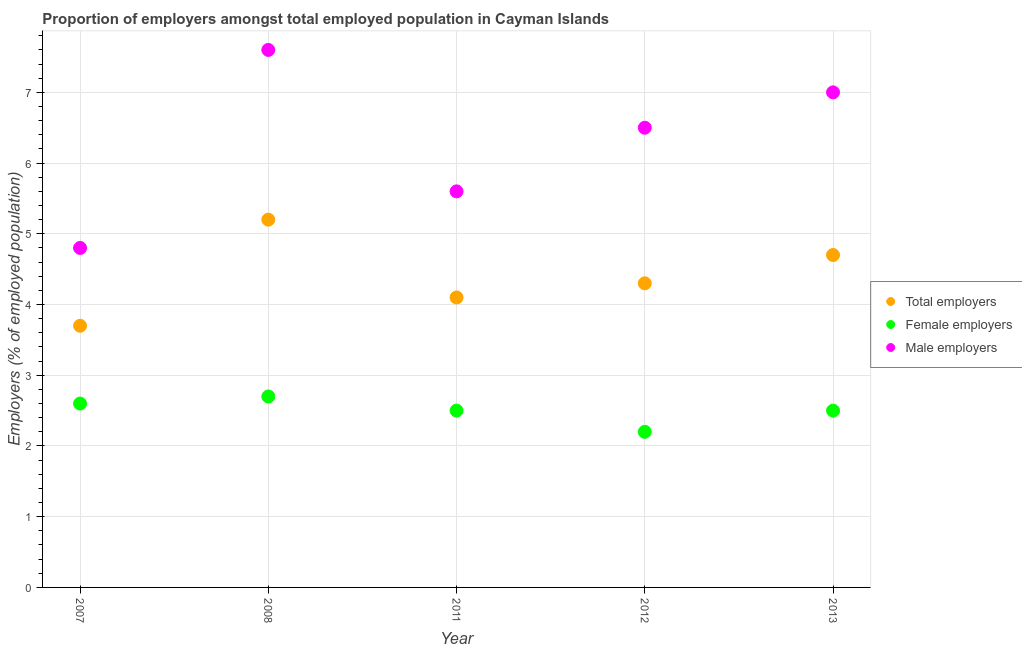What is the percentage of female employers in 2008?
Provide a short and direct response. 2.7. Across all years, what is the maximum percentage of male employers?
Offer a very short reply. 7.6. Across all years, what is the minimum percentage of male employers?
Offer a very short reply. 4.8. In which year was the percentage of female employers maximum?
Your response must be concise. 2008. In which year was the percentage of total employers minimum?
Offer a very short reply. 2007. What is the total percentage of female employers in the graph?
Your answer should be very brief. 12.5. What is the difference between the percentage of female employers in 2008 and that in 2013?
Your answer should be compact. 0.2. What is the difference between the percentage of total employers in 2007 and the percentage of female employers in 2012?
Your answer should be very brief. 1.5. What is the average percentage of female employers per year?
Provide a succinct answer. 2.5. In the year 2011, what is the difference between the percentage of female employers and percentage of total employers?
Provide a short and direct response. -1.6. In how many years, is the percentage of female employers greater than 3.6 %?
Offer a very short reply. 0. What is the ratio of the percentage of total employers in 2011 to that in 2013?
Make the answer very short. 0.87. Is the difference between the percentage of female employers in 2008 and 2013 greater than the difference between the percentage of male employers in 2008 and 2013?
Provide a succinct answer. No. What is the difference between the highest and the lowest percentage of male employers?
Make the answer very short. 2.8. In how many years, is the percentage of total employers greater than the average percentage of total employers taken over all years?
Your answer should be compact. 2. Is the sum of the percentage of female employers in 2008 and 2011 greater than the maximum percentage of male employers across all years?
Provide a short and direct response. No. Is the percentage of female employers strictly less than the percentage of male employers over the years?
Your answer should be compact. Yes. How many dotlines are there?
Your answer should be very brief. 3. How many years are there in the graph?
Your answer should be compact. 5. What is the difference between two consecutive major ticks on the Y-axis?
Your answer should be compact. 1. Are the values on the major ticks of Y-axis written in scientific E-notation?
Ensure brevity in your answer.  No. Does the graph contain any zero values?
Keep it short and to the point. No. How are the legend labels stacked?
Keep it short and to the point. Vertical. What is the title of the graph?
Offer a very short reply. Proportion of employers amongst total employed population in Cayman Islands. Does "Neonatal" appear as one of the legend labels in the graph?
Make the answer very short. No. What is the label or title of the X-axis?
Provide a short and direct response. Year. What is the label or title of the Y-axis?
Give a very brief answer. Employers (% of employed population). What is the Employers (% of employed population) in Total employers in 2007?
Ensure brevity in your answer.  3.7. What is the Employers (% of employed population) in Female employers in 2007?
Ensure brevity in your answer.  2.6. What is the Employers (% of employed population) of Male employers in 2007?
Make the answer very short. 4.8. What is the Employers (% of employed population) of Total employers in 2008?
Ensure brevity in your answer.  5.2. What is the Employers (% of employed population) in Female employers in 2008?
Your answer should be very brief. 2.7. What is the Employers (% of employed population) in Male employers in 2008?
Provide a succinct answer. 7.6. What is the Employers (% of employed population) of Total employers in 2011?
Provide a short and direct response. 4.1. What is the Employers (% of employed population) of Male employers in 2011?
Offer a terse response. 5.6. What is the Employers (% of employed population) of Total employers in 2012?
Provide a short and direct response. 4.3. What is the Employers (% of employed population) of Female employers in 2012?
Your answer should be compact. 2.2. What is the Employers (% of employed population) of Male employers in 2012?
Your answer should be compact. 6.5. What is the Employers (% of employed population) of Total employers in 2013?
Your answer should be very brief. 4.7. What is the Employers (% of employed population) in Male employers in 2013?
Provide a succinct answer. 7. Across all years, what is the maximum Employers (% of employed population) in Total employers?
Your response must be concise. 5.2. Across all years, what is the maximum Employers (% of employed population) in Female employers?
Your answer should be compact. 2.7. Across all years, what is the maximum Employers (% of employed population) in Male employers?
Offer a very short reply. 7.6. Across all years, what is the minimum Employers (% of employed population) of Total employers?
Give a very brief answer. 3.7. Across all years, what is the minimum Employers (% of employed population) of Female employers?
Keep it short and to the point. 2.2. Across all years, what is the minimum Employers (% of employed population) in Male employers?
Your response must be concise. 4.8. What is the total Employers (% of employed population) of Total employers in the graph?
Keep it short and to the point. 22. What is the total Employers (% of employed population) of Male employers in the graph?
Your response must be concise. 31.5. What is the difference between the Employers (% of employed population) in Female employers in 2007 and that in 2008?
Make the answer very short. -0.1. What is the difference between the Employers (% of employed population) of Male employers in 2007 and that in 2008?
Keep it short and to the point. -2.8. What is the difference between the Employers (% of employed population) of Total employers in 2007 and that in 2011?
Your answer should be compact. -0.4. What is the difference between the Employers (% of employed population) in Female employers in 2007 and that in 2011?
Keep it short and to the point. 0.1. What is the difference between the Employers (% of employed population) of Total employers in 2007 and that in 2012?
Your response must be concise. -0.6. What is the difference between the Employers (% of employed population) of Female employers in 2007 and that in 2012?
Keep it short and to the point. 0.4. What is the difference between the Employers (% of employed population) in Total employers in 2008 and that in 2011?
Provide a short and direct response. 1.1. What is the difference between the Employers (% of employed population) of Total employers in 2011 and that in 2012?
Make the answer very short. -0.2. What is the difference between the Employers (% of employed population) in Male employers in 2011 and that in 2012?
Make the answer very short. -0.9. What is the difference between the Employers (% of employed population) in Total employers in 2011 and that in 2013?
Offer a very short reply. -0.6. What is the difference between the Employers (% of employed population) of Female employers in 2011 and that in 2013?
Make the answer very short. 0. What is the difference between the Employers (% of employed population) of Total employers in 2012 and that in 2013?
Offer a very short reply. -0.4. What is the difference between the Employers (% of employed population) in Female employers in 2012 and that in 2013?
Offer a terse response. -0.3. What is the difference between the Employers (% of employed population) of Total employers in 2007 and the Employers (% of employed population) of Female employers in 2011?
Keep it short and to the point. 1.2. What is the difference between the Employers (% of employed population) in Total employers in 2007 and the Employers (% of employed population) in Male employers in 2011?
Offer a very short reply. -1.9. What is the difference between the Employers (% of employed population) of Female employers in 2007 and the Employers (% of employed population) of Male employers in 2011?
Your answer should be very brief. -3. What is the difference between the Employers (% of employed population) in Female employers in 2007 and the Employers (% of employed population) in Male employers in 2013?
Offer a terse response. -4.4. What is the difference between the Employers (% of employed population) in Total employers in 2008 and the Employers (% of employed population) in Male employers in 2011?
Provide a short and direct response. -0.4. What is the difference between the Employers (% of employed population) in Female employers in 2008 and the Employers (% of employed population) in Male employers in 2011?
Offer a terse response. -2.9. What is the difference between the Employers (% of employed population) in Female employers in 2008 and the Employers (% of employed population) in Male employers in 2012?
Offer a very short reply. -3.8. What is the difference between the Employers (% of employed population) of Total employers in 2008 and the Employers (% of employed population) of Male employers in 2013?
Offer a terse response. -1.8. What is the difference between the Employers (% of employed population) of Total employers in 2011 and the Employers (% of employed population) of Male employers in 2012?
Keep it short and to the point. -2.4. What is the difference between the Employers (% of employed population) in Female employers in 2011 and the Employers (% of employed population) in Male employers in 2012?
Provide a short and direct response. -4. What is the difference between the Employers (% of employed population) in Total employers in 2011 and the Employers (% of employed population) in Female employers in 2013?
Ensure brevity in your answer.  1.6. What is the difference between the Employers (% of employed population) of Total employers in 2012 and the Employers (% of employed population) of Male employers in 2013?
Make the answer very short. -2.7. What is the average Employers (% of employed population) in Total employers per year?
Make the answer very short. 4.4. What is the average Employers (% of employed population) in Male employers per year?
Your response must be concise. 6.3. In the year 2007, what is the difference between the Employers (% of employed population) of Total employers and Employers (% of employed population) of Female employers?
Provide a succinct answer. 1.1. In the year 2008, what is the difference between the Employers (% of employed population) of Total employers and Employers (% of employed population) of Female employers?
Provide a short and direct response. 2.5. In the year 2008, what is the difference between the Employers (% of employed population) in Female employers and Employers (% of employed population) in Male employers?
Ensure brevity in your answer.  -4.9. In the year 2011, what is the difference between the Employers (% of employed population) in Total employers and Employers (% of employed population) in Female employers?
Keep it short and to the point. 1.6. In the year 2012, what is the difference between the Employers (% of employed population) in Total employers and Employers (% of employed population) in Female employers?
Keep it short and to the point. 2.1. In the year 2012, what is the difference between the Employers (% of employed population) of Total employers and Employers (% of employed population) of Male employers?
Give a very brief answer. -2.2. What is the ratio of the Employers (% of employed population) of Total employers in 2007 to that in 2008?
Make the answer very short. 0.71. What is the ratio of the Employers (% of employed population) in Male employers in 2007 to that in 2008?
Ensure brevity in your answer.  0.63. What is the ratio of the Employers (% of employed population) of Total employers in 2007 to that in 2011?
Offer a very short reply. 0.9. What is the ratio of the Employers (% of employed population) of Male employers in 2007 to that in 2011?
Offer a very short reply. 0.86. What is the ratio of the Employers (% of employed population) of Total employers in 2007 to that in 2012?
Offer a terse response. 0.86. What is the ratio of the Employers (% of employed population) in Female employers in 2007 to that in 2012?
Your response must be concise. 1.18. What is the ratio of the Employers (% of employed population) in Male employers in 2007 to that in 2012?
Keep it short and to the point. 0.74. What is the ratio of the Employers (% of employed population) in Total employers in 2007 to that in 2013?
Give a very brief answer. 0.79. What is the ratio of the Employers (% of employed population) of Female employers in 2007 to that in 2013?
Offer a very short reply. 1.04. What is the ratio of the Employers (% of employed population) of Male employers in 2007 to that in 2013?
Your response must be concise. 0.69. What is the ratio of the Employers (% of employed population) of Total employers in 2008 to that in 2011?
Your answer should be very brief. 1.27. What is the ratio of the Employers (% of employed population) in Male employers in 2008 to that in 2011?
Keep it short and to the point. 1.36. What is the ratio of the Employers (% of employed population) in Total employers in 2008 to that in 2012?
Ensure brevity in your answer.  1.21. What is the ratio of the Employers (% of employed population) in Female employers in 2008 to that in 2012?
Your answer should be compact. 1.23. What is the ratio of the Employers (% of employed population) in Male employers in 2008 to that in 2012?
Ensure brevity in your answer.  1.17. What is the ratio of the Employers (% of employed population) of Total employers in 2008 to that in 2013?
Give a very brief answer. 1.11. What is the ratio of the Employers (% of employed population) in Female employers in 2008 to that in 2013?
Your response must be concise. 1.08. What is the ratio of the Employers (% of employed population) in Male employers in 2008 to that in 2013?
Ensure brevity in your answer.  1.09. What is the ratio of the Employers (% of employed population) in Total employers in 2011 to that in 2012?
Offer a terse response. 0.95. What is the ratio of the Employers (% of employed population) of Female employers in 2011 to that in 2012?
Give a very brief answer. 1.14. What is the ratio of the Employers (% of employed population) of Male employers in 2011 to that in 2012?
Provide a succinct answer. 0.86. What is the ratio of the Employers (% of employed population) in Total employers in 2011 to that in 2013?
Provide a succinct answer. 0.87. What is the ratio of the Employers (% of employed population) in Female employers in 2011 to that in 2013?
Give a very brief answer. 1. What is the ratio of the Employers (% of employed population) in Male employers in 2011 to that in 2013?
Offer a very short reply. 0.8. What is the ratio of the Employers (% of employed population) in Total employers in 2012 to that in 2013?
Your answer should be compact. 0.91. What is the difference between the highest and the second highest Employers (% of employed population) in Total employers?
Your answer should be compact. 0.5. What is the difference between the highest and the lowest Employers (% of employed population) of Total employers?
Provide a short and direct response. 1.5. What is the difference between the highest and the lowest Employers (% of employed population) of Male employers?
Make the answer very short. 2.8. 